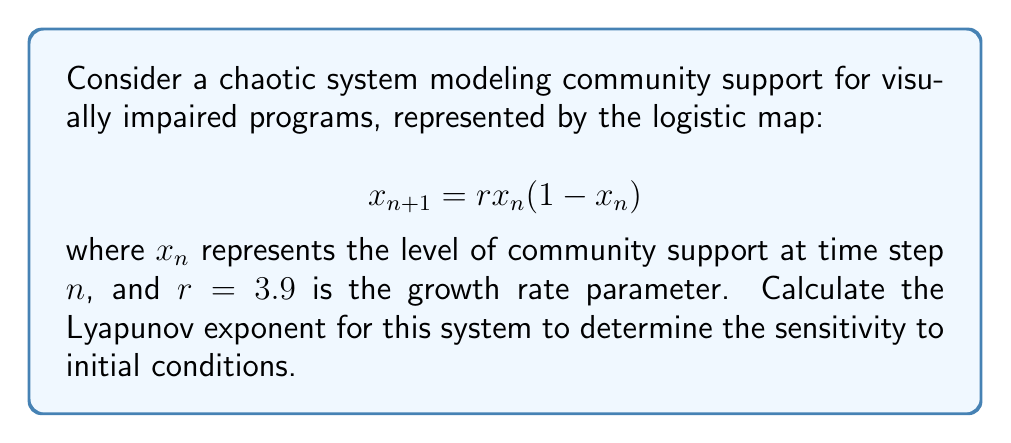Help me with this question. To compute the Lyapunov exponent for this discrete-time system:

1) The Lyapunov exponent $\lambda$ is given by:

   $$\lambda = \lim_{N \to \infty} \frac{1}{N} \sum_{n=0}^{N-1} \ln |f'(x_n)|$$

   where $f'(x_n)$ is the derivative of the map at $x_n$.

2) For the logistic map, $f(x) = rx(1-x)$, so $f'(x) = r(1-2x)$.

3) Choose an initial condition, e.g., $x_0 = 0.5$.

4) Iterate the map for a large number of steps (e.g., $N = 1000$), computing $x_n$ and $\ln |f'(x_n)|$ at each step:

   $$x_{n+1} = 3.9x_n(1-x_n)$$
   $$\ln |f'(x_n)| = \ln |3.9(1-2x_n)|$$

5) Sum the $\ln |f'(x_n)|$ values and divide by $N$:

   $$\lambda \approx \frac{1}{N} \sum_{n=0}^{N-1} \ln |3.9(1-2x_n)|$$

6) Using a computer or calculator to perform these iterations, we find:

   $$\lambda \approx 0.6936$$

This positive Lyapunov exponent indicates that the system is chaotic, meaning small changes in initial community support levels can lead to significantly different outcomes over time.
Answer: $\lambda \approx 0.6936$ 